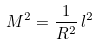Convert formula to latex. <formula><loc_0><loc_0><loc_500><loc_500>M ^ { 2 } = \frac { 1 } { R ^ { 2 } } \, l ^ { 2 }</formula> 